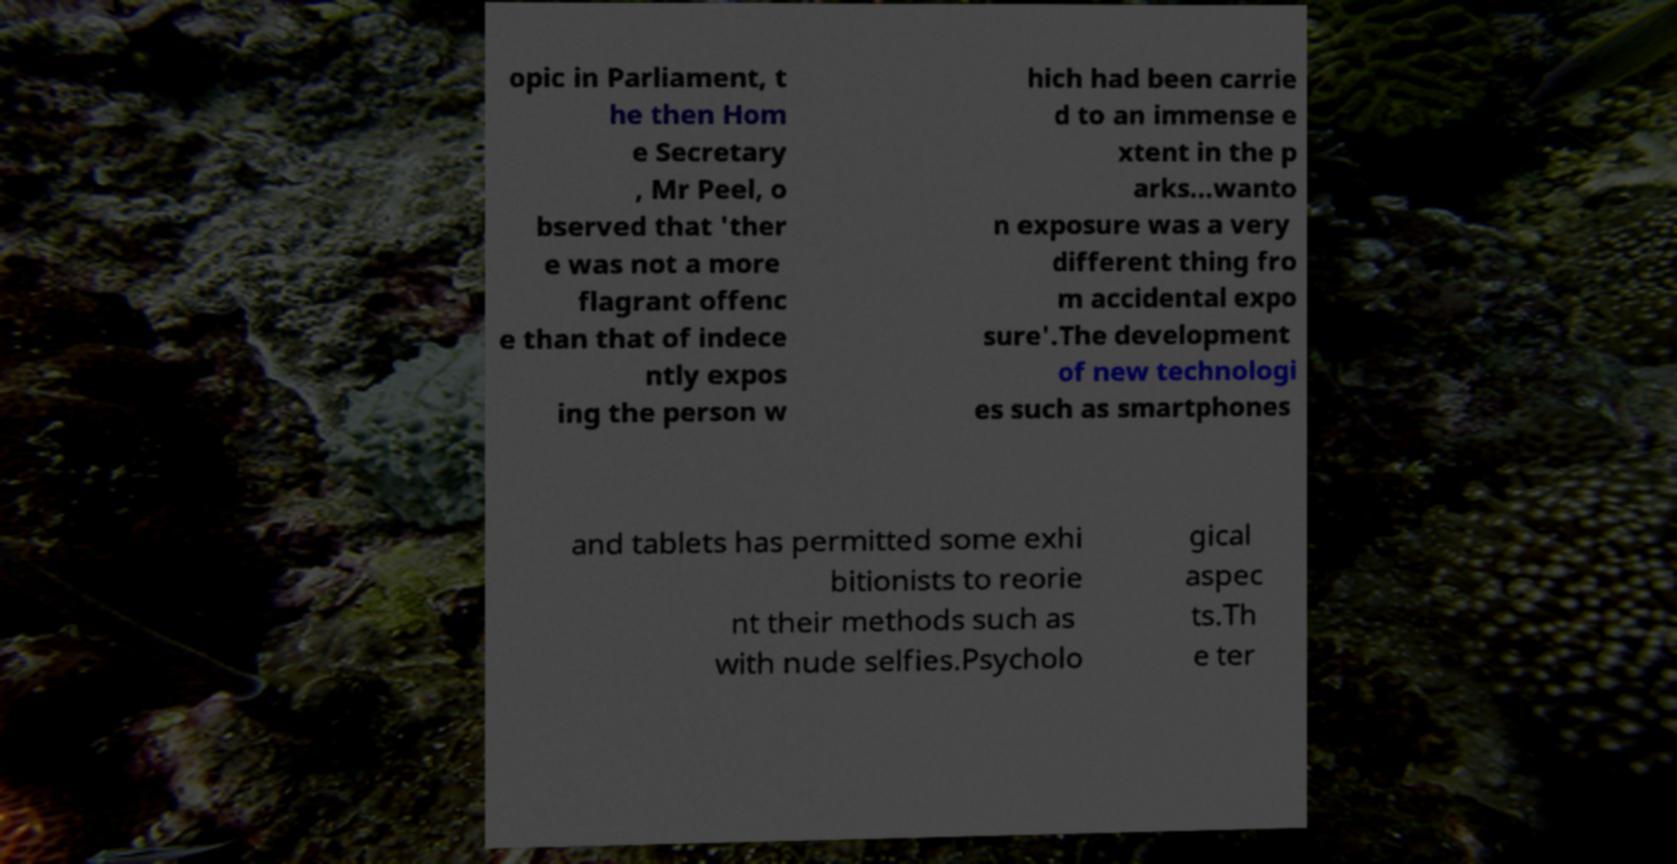Could you assist in decoding the text presented in this image and type it out clearly? opic in Parliament, t he then Hom e Secretary , Mr Peel, o bserved that 'ther e was not a more flagrant offenc e than that of indece ntly expos ing the person w hich had been carrie d to an immense e xtent in the p arks...wanto n exposure was a very different thing fro m accidental expo sure'.The development of new technologi es such as smartphones and tablets has permitted some exhi bitionists to reorie nt their methods such as with nude selfies.Psycholo gical aspec ts.Th e ter 